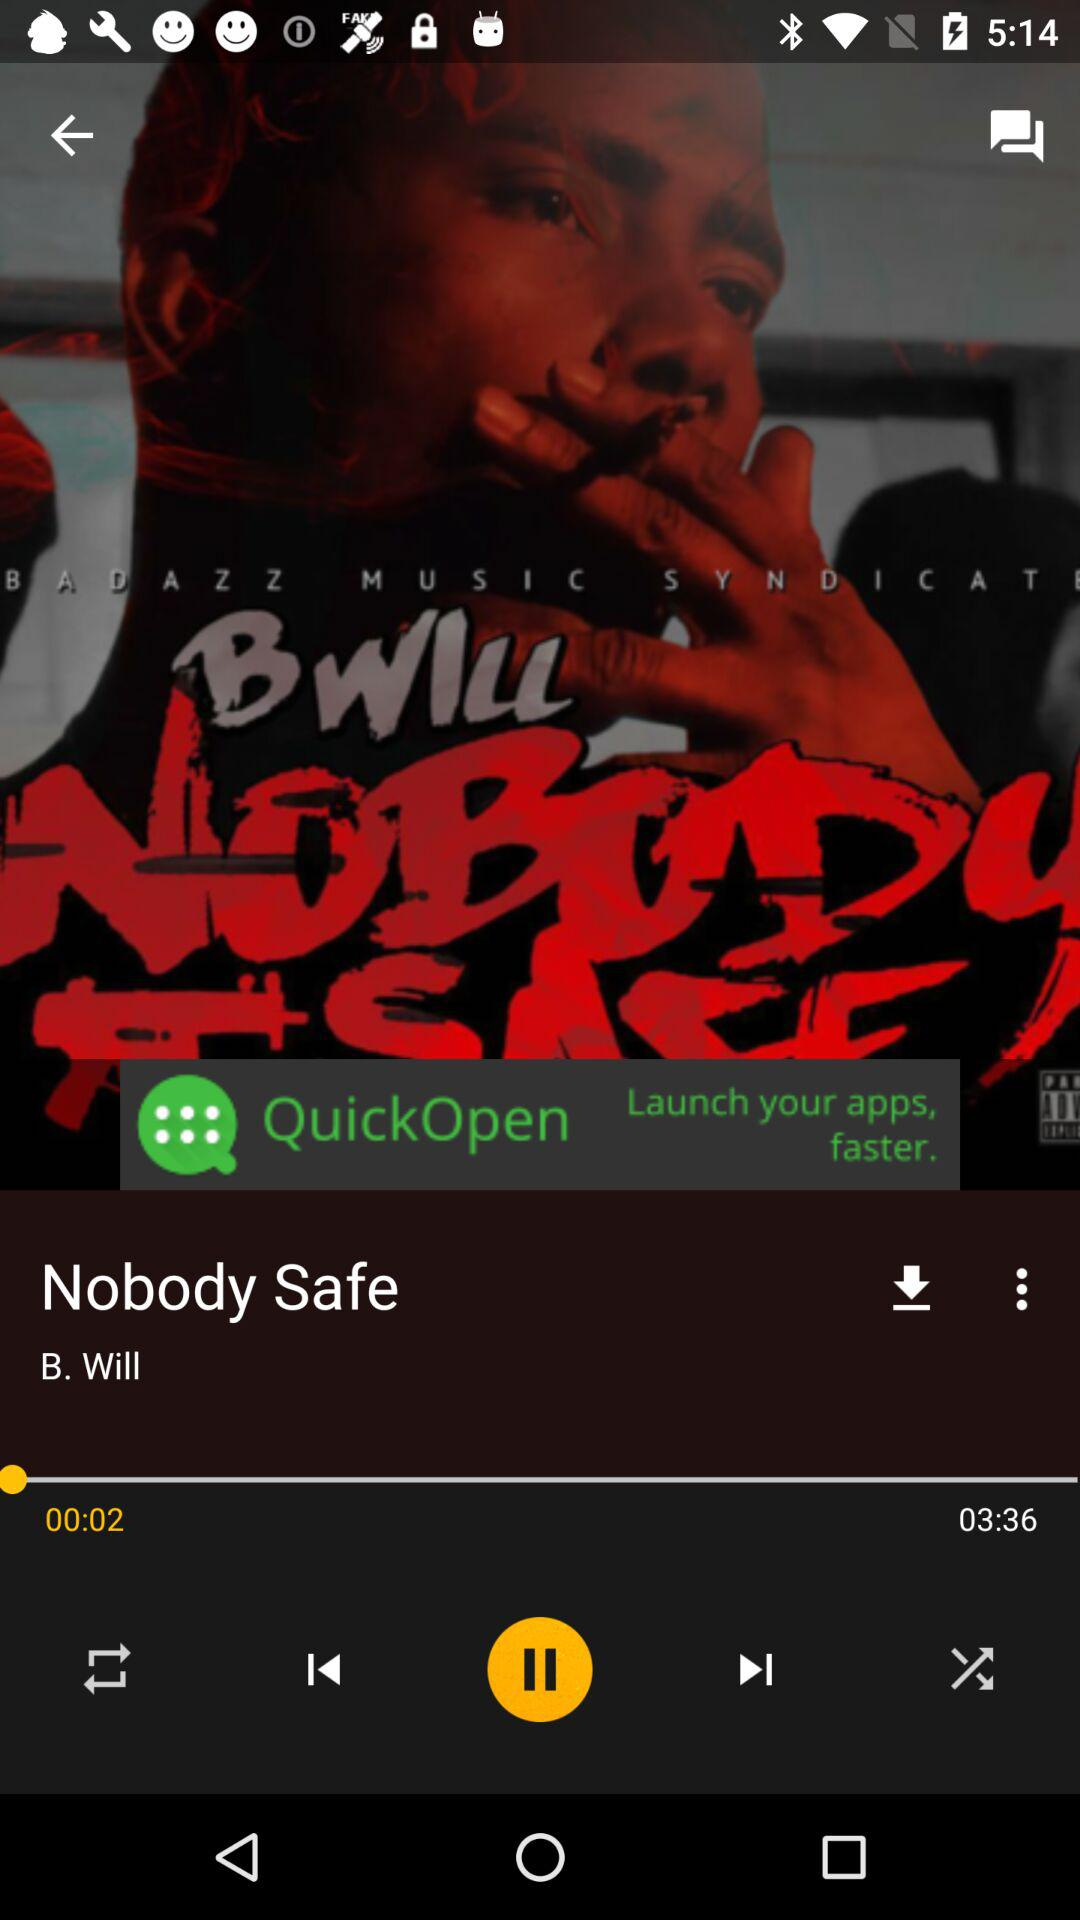What is the name of the video? The name of the video is "Nobody Safe". 